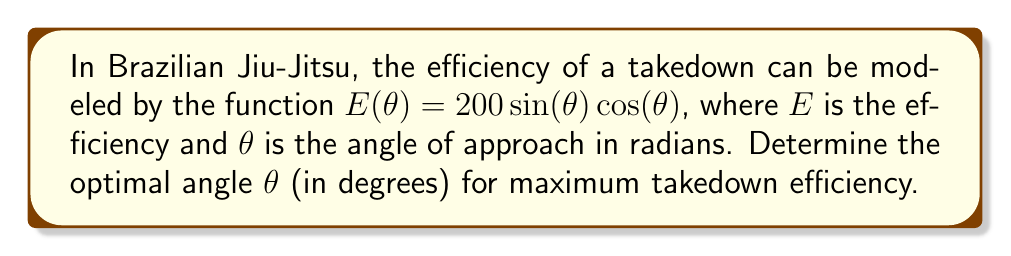Give your solution to this math problem. To find the optimal angle for maximum efficiency, we need to find the maximum of the function $E(\theta)$. This can be done by following these steps:

1) First, we need to find the derivative of $E(\theta)$:
   
   $E(\theta) = 200\sin(\theta)\cos(\theta)$
   
   Using the product rule and the derivatives of sine and cosine:
   
   $E'(\theta) = 200(\cos^2(\theta) - \sin^2(\theta))$

2) To find the maximum, we set the derivative equal to zero:
   
   $200(\cos^2(\theta) - \sin^2(\theta)) = 0$
   
   $\cos^2(\theta) - \sin^2(\theta) = 0$

3) We can use the trigonometric identity $\cos^2(\theta) + \sin^2(\theta) = 1$ to simplify:
   
   $\cos^2(\theta) = \sin^2(\theta)$
   
   $\cos^2(\theta) = 1 - \cos^2(\theta)$
   
   $2\cos^2(\theta) = 1$
   
   $\cos^2(\theta) = \frac{1}{2}$

4) Taking the square root of both sides:
   
   $\cos(\theta) = \pm\frac{1}{\sqrt{2}}$

5) The positive solution in the first quadrant is:
   
   $\theta = \arccos(\frac{1}{\sqrt{2}})$

6) Converting to degrees:
   
   $\theta = \arccos(\frac{1}{\sqrt{2}}) \cdot \frac{180}{\pi} \approx 45°$

Therefore, the optimal angle for maximum takedown efficiency is approximately 45 degrees.
Answer: 45° 